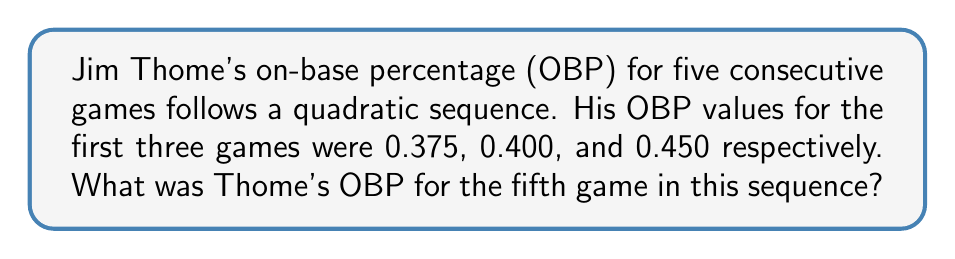Provide a solution to this math problem. Let's approach this step-by-step:

1) In a quadratic sequence, the second difference between terms is constant. Let's calculate the differences:

   First differences:
   0.400 - 0.375 = 0.025
   0.450 - 0.400 = 0.050

   Second difference:
   0.050 - 0.025 = 0.025

2) The general form of a quadratic sequence is:
   $$a_n = an^2 + bn + c$$
   where $n$ is the term number (starting from 0).

3) We can set up a system of equations using the first three terms:
   $$0.375 = a(0)^2 + b(0) + c$$
   $$0.400 = a(1)^2 + b(1) + c$$
   $$0.450 = a(2)^2 + b(2) + c$$

4) From the first equation: $c = 0.375$

5) Subtracting the first equation from the second:
   $$0.025 = a + b$$

6) Subtracting the second equation from the third:
   $$0.050 = 3a + b$$

7) Subtracting equation in step 5 from equation in step 6:
   $$0.025 = 2a$$
   $$a = 0.0125$$

8) Substituting back into the equation from step 5:
   $$0.025 = 0.0125 + b$$
   $$b = 0.0125$$

9) Now we have the quadratic sequence:
   $$a_n = 0.0125n^2 + 0.0125n + 0.375$$

10) To find the 5th term (n = 4), we calculate:
    $$a_4 = 0.0125(4)^2 + 0.0125(4) + 0.375$$
    $$a_4 = 0.2 + 0.05 + 0.375 = 0.625$$

Therefore, Jim Thome's OBP for the fifth game was 0.625.
Answer: 0.625 